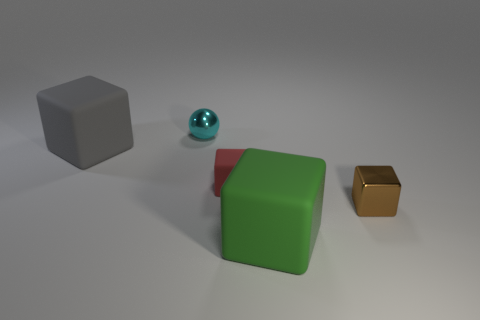There is a rubber object that is in front of the small cube that is on the right side of the green cube; what number of small things are in front of it?
Make the answer very short. 0. There is a sphere that is the same size as the red cube; what color is it?
Provide a succinct answer. Cyan. What size is the metal cube in front of the tiny block behind the small brown cube?
Your response must be concise. Small. What number of other objects are there of the same size as the gray matte thing?
Offer a very short reply. 1. How many purple balls are there?
Provide a short and direct response. 0. Is the brown shiny thing the same size as the green rubber thing?
Give a very brief answer. No. What number of other things are the same shape as the small brown shiny object?
Give a very brief answer. 3. What is the material of the big thing on the right side of the large matte thing left of the big green matte cube?
Offer a terse response. Rubber. Are there any cyan shiny things on the right side of the shiny ball?
Ensure brevity in your answer.  No. Is the size of the brown metal thing the same as the cyan object behind the red matte object?
Give a very brief answer. Yes. 